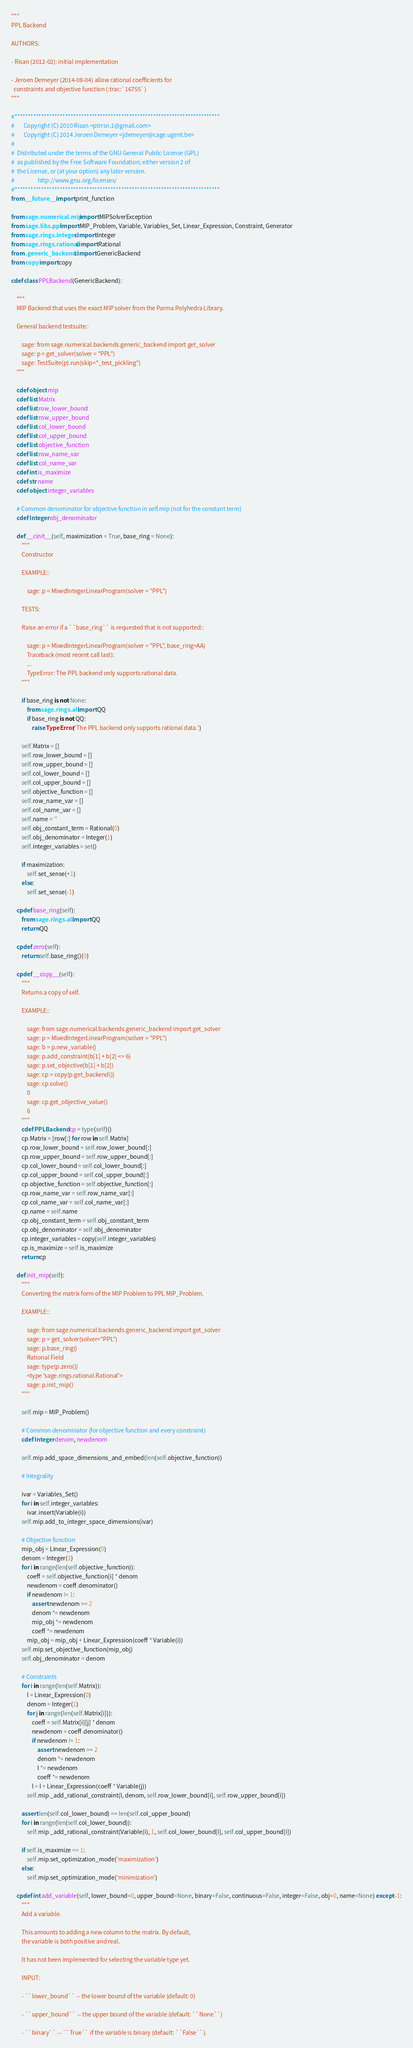Convert code to text. <code><loc_0><loc_0><loc_500><loc_500><_Cython_>"""
PPL Backend

AUTHORS:

- Risan (2012-02): initial implementation

- Jeroen Demeyer (2014-08-04) allow rational coefficients for
  constraints and objective function (:trac:`16755`)
"""

#*****************************************************************************
#       Copyright (C) 2010 Risan <ptrrsn.1@gmail.com>
#       Copyright (C) 2014 Jeroen Demeyer <jdemeyer@cage.ugent.be>
#
#  Distributed under the terms of the GNU General Public License (GPL)
#  as published by the Free Software Foundation; either version 2 of
#  the License, or (at your option) any later version.
#                  http://www.gnu.org/licenses/
#*****************************************************************************
from __future__ import print_function

from sage.numerical.mip import MIPSolverException
from sage.libs.ppl import MIP_Problem, Variable, Variables_Set, Linear_Expression, Constraint, Generator
from sage.rings.integer cimport Integer
from sage.rings.rational cimport Rational
from .generic_backend cimport GenericBackend
from copy import copy

cdef class PPLBackend(GenericBackend):

    """
    MIP Backend that uses the exact MIP solver from the Parma Polyhedra Library.

    General backend testsuite::

        sage: from sage.numerical.backends.generic_backend import get_solver
        sage: p = get_solver(solver = "PPL")
        sage: TestSuite(p).run(skip="_test_pickling")
    """

    cdef object mip
    cdef list Matrix
    cdef list row_lower_bound
    cdef list row_upper_bound
    cdef list col_lower_bound
    cdef list col_upper_bound
    cdef list objective_function
    cdef list row_name_var
    cdef list col_name_var
    cdef int is_maximize
    cdef str name
    cdef object integer_variables

    # Common denominator for objective function in self.mip (not for the constant term)
    cdef Integer obj_denominator

    def __cinit__(self, maximization = True, base_ring = None):
        """
        Constructor

        EXAMPLE::

            sage: p = MixedIntegerLinearProgram(solver = "PPL")

        TESTS:

        Raise an error if a ``base_ring`` is requested that is not supported::

            sage: p = MixedIntegerLinearProgram(solver = "PPL", base_ring=AA)
            Traceback (most recent call last):
            ...
            TypeError: The PPL backend only supports rational data.
        """

        if base_ring is not None:
            from sage.rings.all import QQ
            if base_ring is not QQ:
                raise TypeError('The PPL backend only supports rational data.')

        self.Matrix = []
        self.row_lower_bound = []
        self.row_upper_bound = []
        self.col_lower_bound = []
        self.col_upper_bound = []
        self.objective_function = []
        self.row_name_var = []
        self.col_name_var = []
        self.name = ''
        self.obj_constant_term = Rational(0)
        self.obj_denominator = Integer(1)
        self.integer_variables = set()

        if maximization:
            self.set_sense(+1)
        else:
            self.set_sense(-1)

    cpdef base_ring(self):
        from sage.rings.all import QQ
        return QQ

    cpdef zero(self):
        return self.base_ring()(0)

    cpdef __copy__(self):
        """
        Returns a copy of self.

        EXAMPLE::

            sage: from sage.numerical.backends.generic_backend import get_solver
            sage: p = MixedIntegerLinearProgram(solver = "PPL")
            sage: b = p.new_variable()
            sage: p.add_constraint(b[1] + b[2] <= 6)
            sage: p.set_objective(b[1] + b[2])
            sage: cp = copy(p.get_backend())
            sage: cp.solve()
            0
            sage: cp.get_objective_value()
            6
        """
        cdef PPLBackend cp = type(self)()
        cp.Matrix = [row[:] for row in self.Matrix]
        cp.row_lower_bound = self.row_lower_bound[:]
        cp.row_upper_bound = self.row_upper_bound[:]
        cp.col_lower_bound = self.col_lower_bound[:]
        cp.col_upper_bound = self.col_upper_bound[:]
        cp.objective_function = self.objective_function[:]
        cp.row_name_var = self.row_name_var[:]
        cp.col_name_var = self.col_name_var[:]
        cp.name = self.name
        cp.obj_constant_term = self.obj_constant_term
        cp.obj_denominator = self.obj_denominator
        cp.integer_variables = copy(self.integer_variables)
        cp.is_maximize = self.is_maximize
        return cp

    def init_mip(self):
        """
        Converting the matrix form of the MIP Problem to PPL MIP_Problem.

        EXAMPLE::

            sage: from sage.numerical.backends.generic_backend import get_solver
            sage: p = get_solver(solver="PPL")
            sage: p.base_ring()
            Rational Field
            sage: type(p.zero())
            <type 'sage.rings.rational.Rational'>
            sage: p.init_mip()
        """

        self.mip = MIP_Problem()

        # Common denominator (for objective function and every constraint)
        cdef Integer denom, newdenom

        self.mip.add_space_dimensions_and_embed(len(self.objective_function))

        # Integrality

        ivar = Variables_Set()
        for i in self.integer_variables:
            ivar.insert(Variable(i))
        self.mip.add_to_integer_space_dimensions(ivar)

        # Objective function
        mip_obj = Linear_Expression(0)
        denom = Integer(1)
        for i in range(len(self.objective_function)):
            coeff = self.objective_function[i] * denom
            newdenom = coeff.denominator()
            if newdenom != 1:
                assert newdenom >= 2
                denom *= newdenom
                mip_obj *= newdenom
                coeff *= newdenom
            mip_obj = mip_obj + Linear_Expression(coeff * Variable(i))
        self.mip.set_objective_function(mip_obj)
        self.obj_denominator = denom
        
        # Constraints
        for i in range(len(self.Matrix)):
            l = Linear_Expression(0)
            denom = Integer(1)
            for j in range(len(self.Matrix[i])):
                coeff = self.Matrix[i][j] * denom
                newdenom = coeff.denominator()
                if newdenom != 1:
                    assert newdenom >= 2
                    denom *= newdenom
                    l *= newdenom
                    coeff *= newdenom
                l = l + Linear_Expression(coeff * Variable(j))
            self.mip._add_rational_constraint(l, denom, self.row_lower_bound[i], self.row_upper_bound[i])

        assert len(self.col_lower_bound) == len(self.col_upper_bound)
        for i in range(len(self.col_lower_bound)):
            self.mip._add_rational_constraint(Variable(i), 1, self.col_lower_bound[i], self.col_upper_bound[i])

        if self.is_maximize == 1:
            self.mip.set_optimization_mode('maximization')
        else:
            self.mip.set_optimization_mode('minimization')

    cpdef int add_variable(self, lower_bound=0, upper_bound=None, binary=False, continuous=False, integer=False, obj=0, name=None) except -1:
        """
        Add a variable.

        This amounts to adding a new column to the matrix. By default,
        the variable is both positive and real.

        It has not been implemented for selecting the variable type yet.

        INPUT:

        - ``lower_bound`` -- the lower bound of the variable (default: 0)

        - ``upper_bound`` -- the upper bound of the variable (default: ``None``)

        - ``binary`` -- ``True`` if the variable is binary (default: ``False``).
</code> 